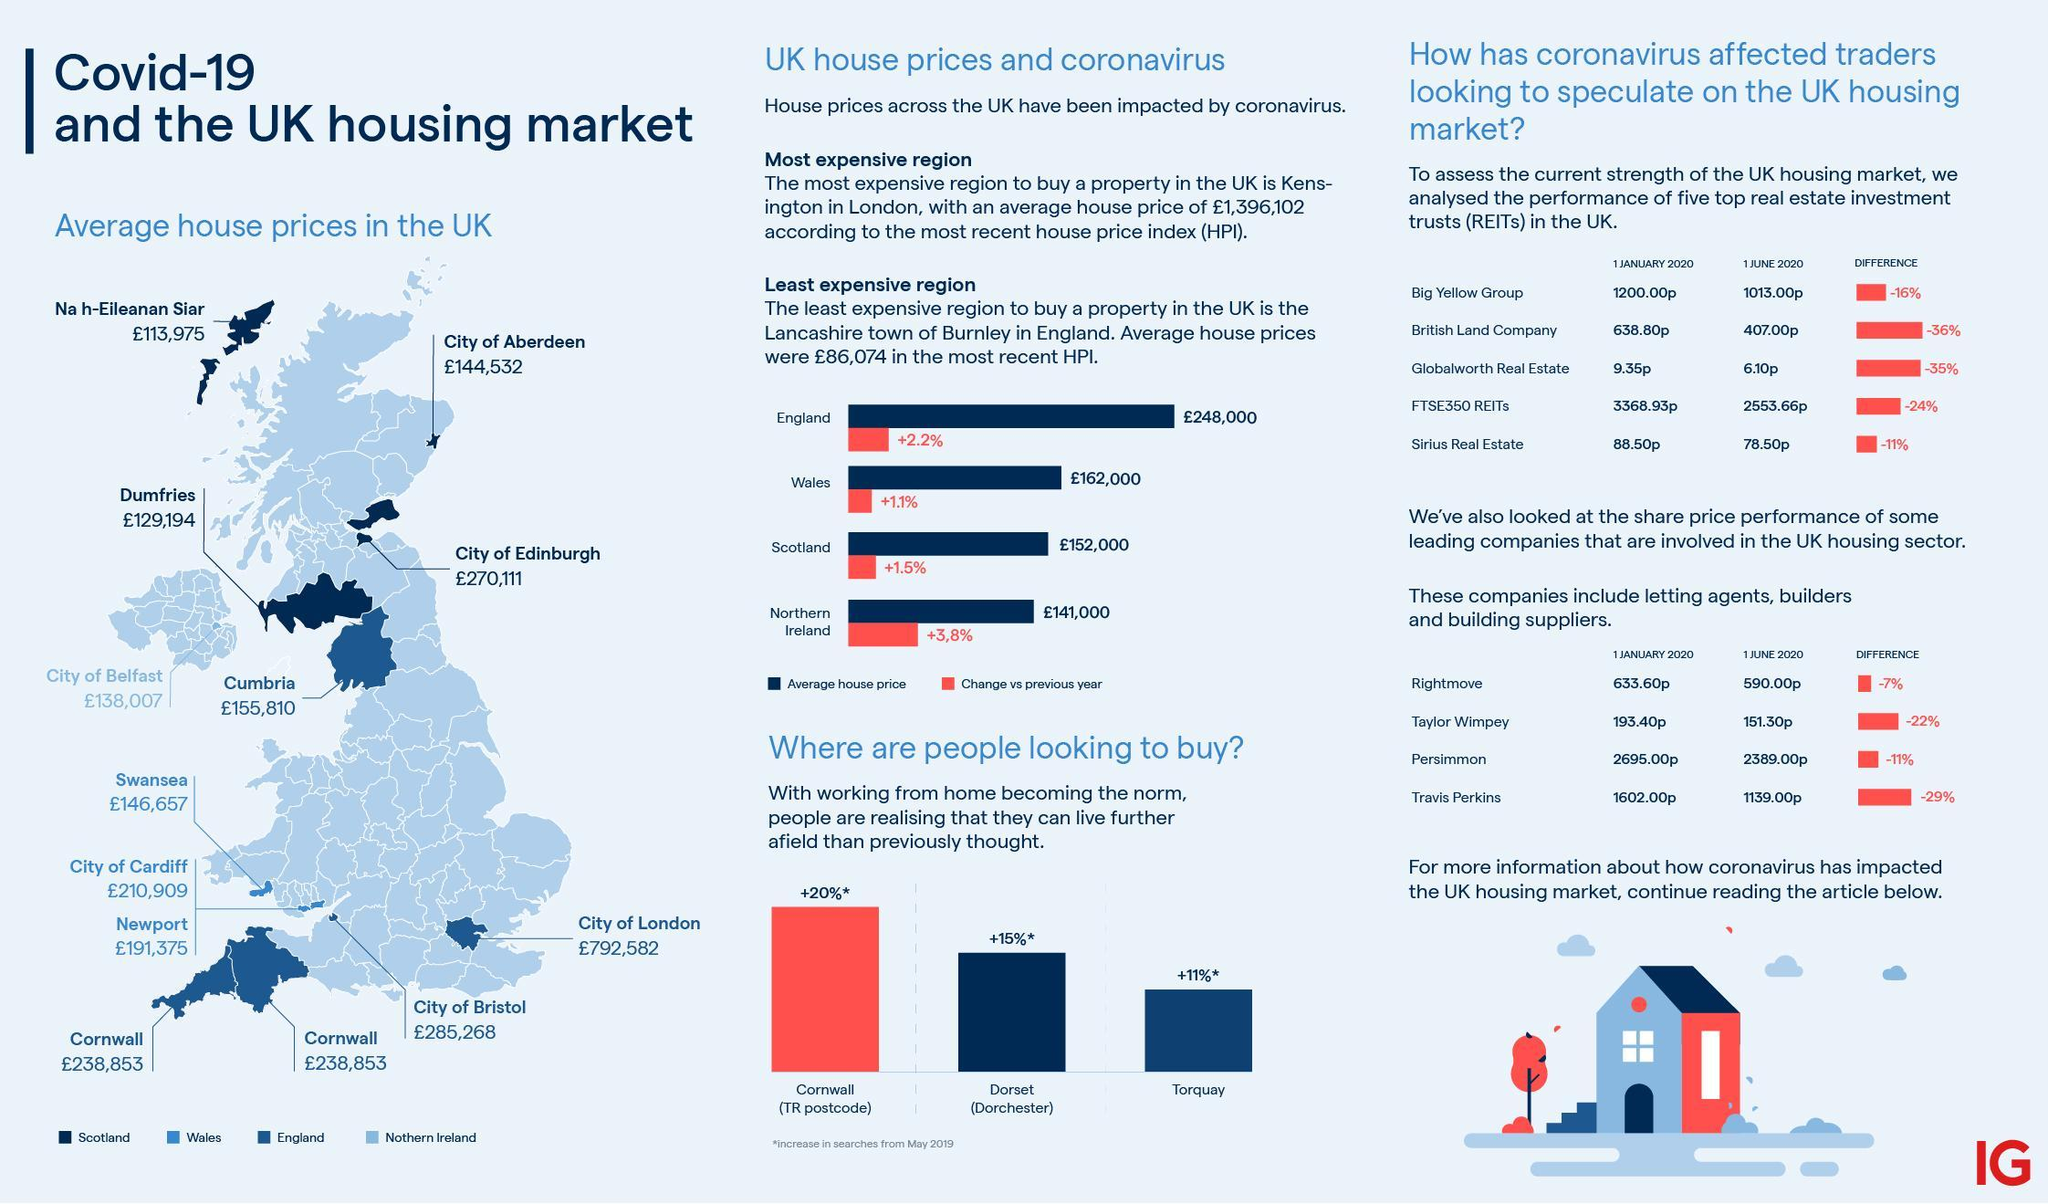List a handful of essential elements in this visual. The average house price in the City of London is £792,582. The average house price in the City of Bristol is approximately 285,268 pounds. 